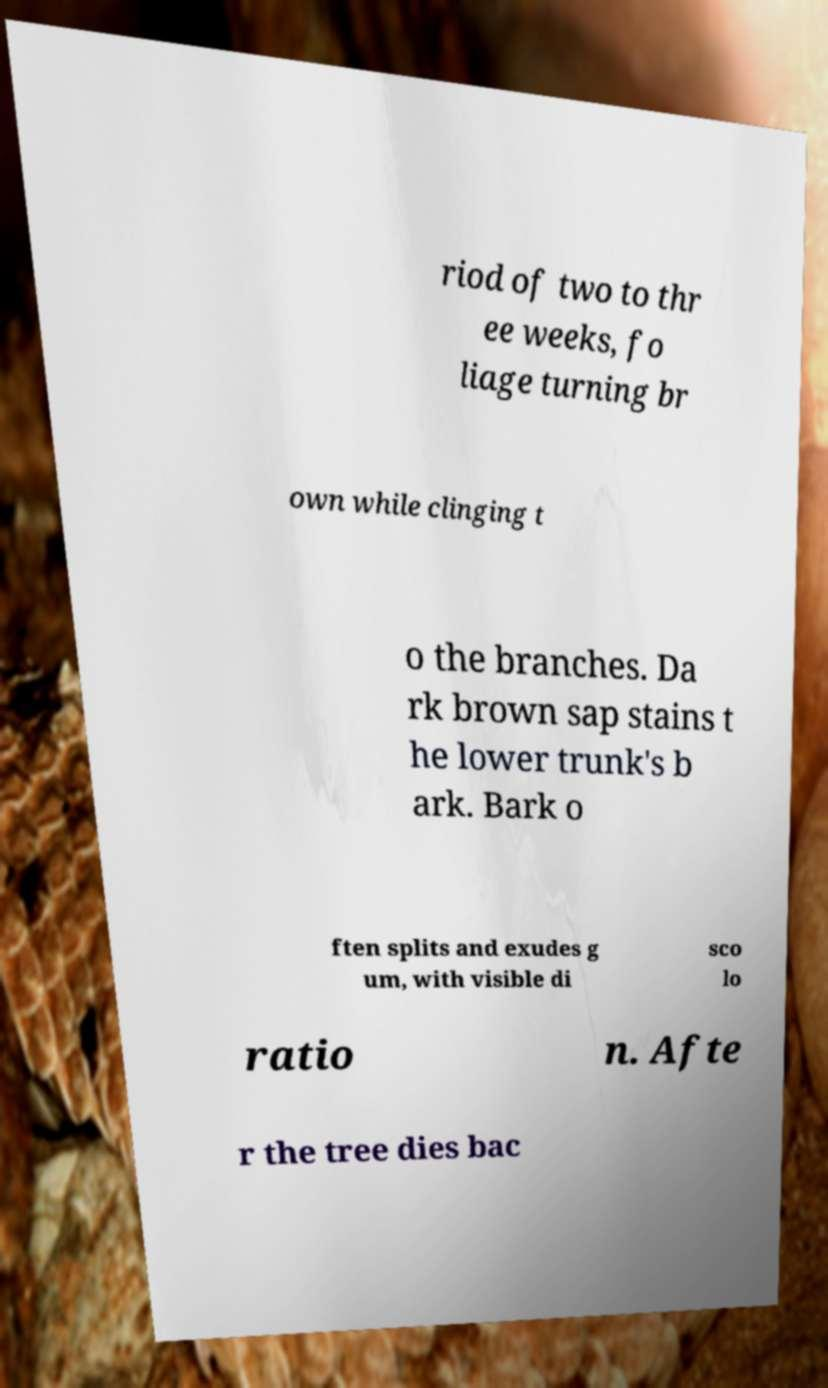Please read and relay the text visible in this image. What does it say? riod of two to thr ee weeks, fo liage turning br own while clinging t o the branches. Da rk brown sap stains t he lower trunk's b ark. Bark o ften splits and exudes g um, with visible di sco lo ratio n. Afte r the tree dies bac 